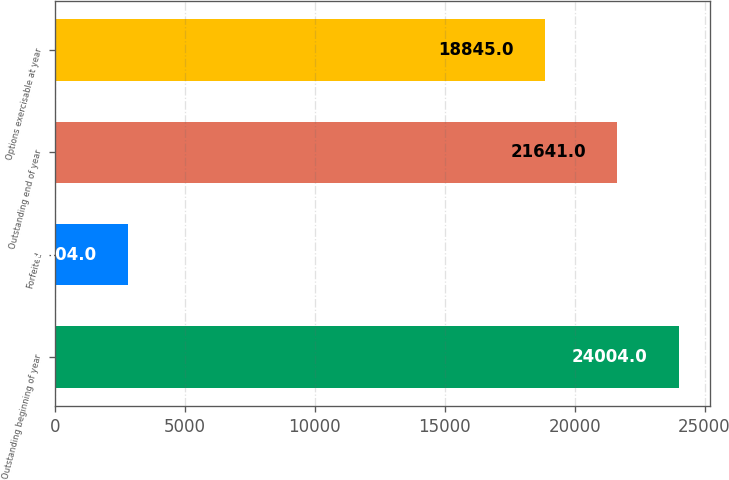<chart> <loc_0><loc_0><loc_500><loc_500><bar_chart><fcel>Outstanding beginning of year<fcel>Forfeited<fcel>Outstanding end of year<fcel>Options exercisable at year<nl><fcel>24004<fcel>2804<fcel>21641<fcel>18845<nl></chart> 